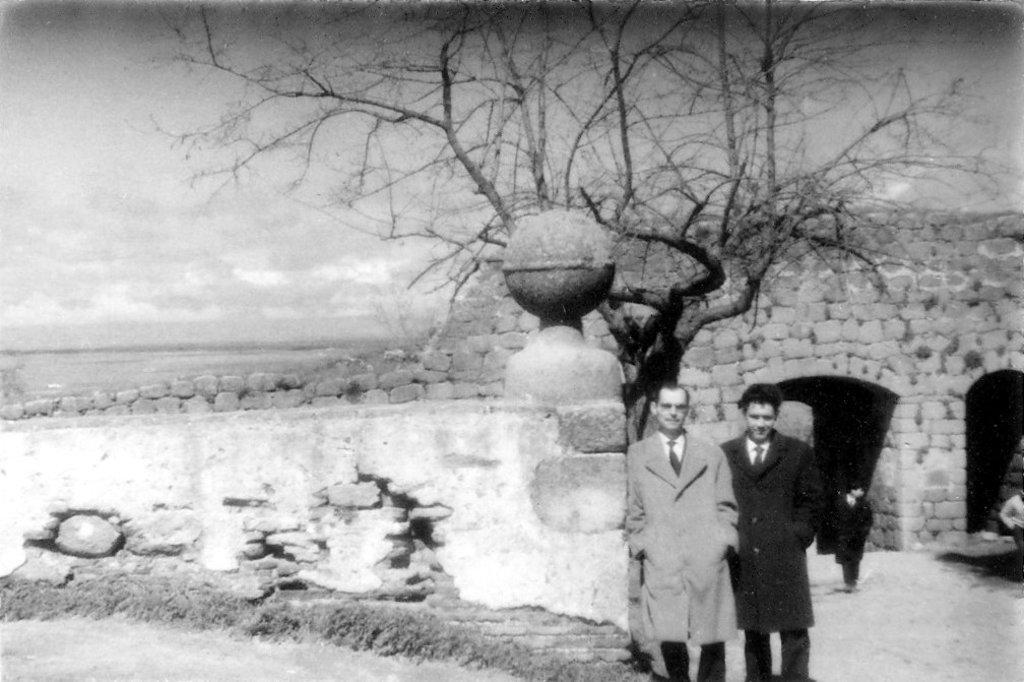In one or two sentences, can you explain what this image depicts? In this image I can see two persons standing, background I can see the wall, a dried tree and the sky and the image is in black and white. 